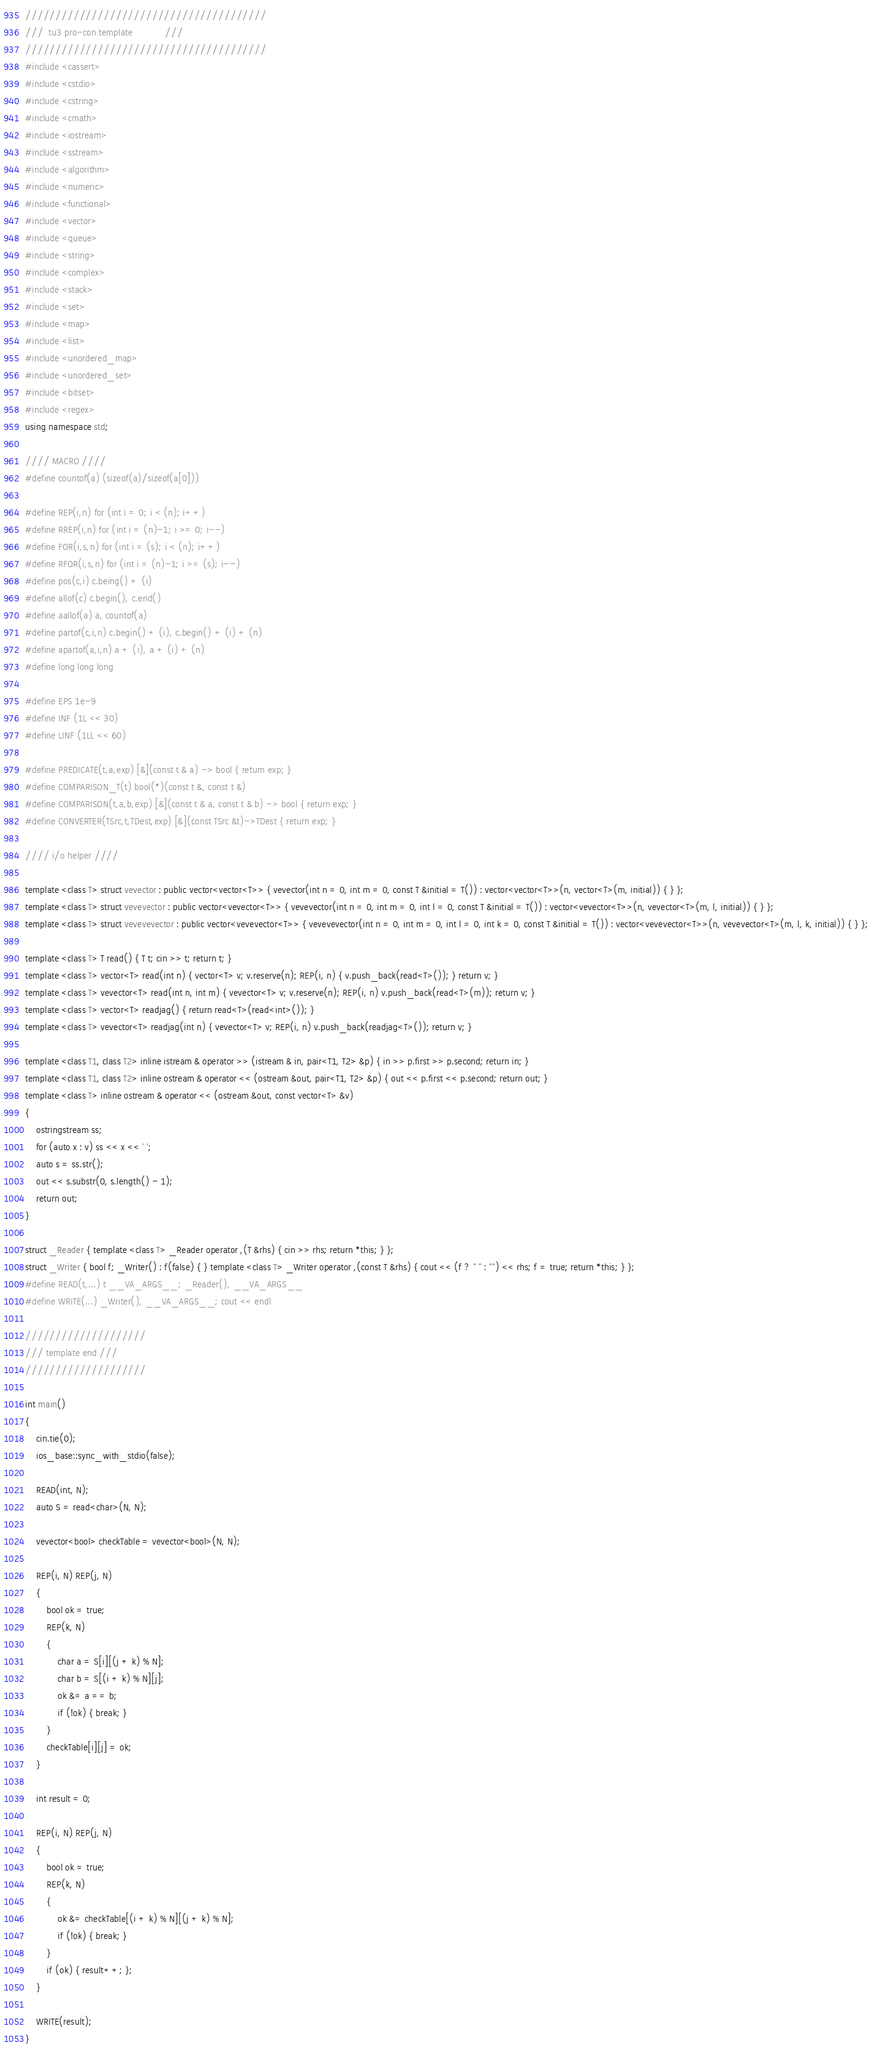Convert code to text. <code><loc_0><loc_0><loc_500><loc_500><_C++_>////////////////////////////////////////
///  tu3 pro-con template            ///
////////////////////////////////////////
#include <cassert>
#include <cstdio>
#include <cstring>
#include <cmath>
#include <iostream>
#include <sstream>
#include <algorithm>
#include <numeric>
#include <functional>
#include <vector>
#include <queue>
#include <string>
#include <complex>
#include <stack>
#include <set>
#include <map>
#include <list>
#include <unordered_map>
#include <unordered_set>
#include <bitset>
#include <regex>
using namespace std;

//// MACRO ////
#define countof(a) (sizeof(a)/sizeof(a[0]))

#define REP(i,n) for (int i = 0; i < (n); i++)
#define RREP(i,n) for (int i = (n)-1; i >= 0; i--)
#define FOR(i,s,n) for (int i = (s); i < (n); i++)
#define RFOR(i,s,n) for (int i = (n)-1; i >= (s); i--)
#define pos(c,i) c.being() + (i)
#define allof(c) c.begin(), c.end()
#define aallof(a) a, countof(a)
#define partof(c,i,n) c.begin() + (i), c.begin() + (i) + (n)
#define apartof(a,i,n) a + (i), a + (i) + (n)
#define long long long

#define EPS 1e-9
#define INF (1L << 30)
#define LINF (1LL << 60)

#define PREDICATE(t,a,exp) [&](const t & a) -> bool { return exp; }
#define COMPARISON_T(t) bool(*)(const t &, const t &)
#define COMPARISON(t,a,b,exp) [&](const t & a, const t & b) -> bool { return exp; }
#define CONVERTER(TSrc,t,TDest,exp) [&](const TSrc &t)->TDest { return exp; }

//// i/o helper ////

template <class T> struct vevector : public vector<vector<T>> { vevector(int n = 0, int m = 0, const T &initial = T()) : vector<vector<T>>(n, vector<T>(m, initial)) { } };
template <class T> struct vevevector : public vector<vevector<T>> { vevevector(int n = 0, int m = 0, int l = 0, const T &initial = T()) : vector<vevector<T>>(n, vevector<T>(m, l, initial)) { } };
template <class T> struct vevevevector : public vector<vevevector<T>> { vevevevector(int n = 0, int m = 0, int l = 0, int k = 0, const T &initial = T()) : vector<vevevector<T>>(n, vevevector<T>(m, l, k, initial)) { } };

template <class T> T read() { T t; cin >> t; return t; }
template <class T> vector<T> read(int n) { vector<T> v; v.reserve(n); REP(i, n) { v.push_back(read<T>()); } return v; }
template <class T> vevector<T> read(int n, int m) { vevector<T> v; v.reserve(n); REP(i, n) v.push_back(read<T>(m)); return v; }
template <class T> vector<T> readjag() { return read<T>(read<int>()); }
template <class T> vevector<T> readjag(int n) { vevector<T> v; REP(i, n) v.push_back(readjag<T>()); return v; }

template <class T1, class T2> inline istream & operator >> (istream & in, pair<T1, T2> &p) { in >> p.first >> p.second; return in; }
template <class T1, class T2> inline ostream & operator << (ostream &out, pair<T1, T2> &p) { out << p.first << p.second; return out; }
template <class T> inline ostream & operator << (ostream &out, const vector<T> &v)
{
	ostringstream ss;
	for (auto x : v) ss << x << ' ';
	auto s = ss.str();
	out << s.substr(0, s.length() - 1);
	return out;
}

struct _Reader { template <class T> _Reader operator ,(T &rhs) { cin >> rhs; return *this; } };
struct _Writer { bool f; _Writer() : f(false) { } template <class T> _Writer operator ,(const T &rhs) { cout << (f ? " " : "") << rhs; f = true; return *this; } };
#define READ(t,...) t __VA_ARGS__; _Reader(), __VA_ARGS__
#define WRITE(...) _Writer(), __VA_ARGS__; cout << endl

////////////////////
/// template end ///
////////////////////

int main()
{
	cin.tie(0);
	ios_base::sync_with_stdio(false);

	READ(int, N);
	auto S = read<char>(N, N);

	vevector<bool> checkTable = vevector<bool>(N, N);

	REP(i, N) REP(j, N)
	{
		bool ok = true;
		REP(k, N)
		{
			char a = S[i][(j + k) % N];
			char b = S[(i + k) % N][j];
			ok &= a == b;
			if (!ok) { break; }
		}
		checkTable[i][j] = ok;
	}

	int result = 0;

	REP(i, N) REP(j, N)
	{
		bool ok = true;
		REP(k, N)
		{
			ok &= checkTable[(i + k) % N][(j + k) % N];
			if (!ok) { break; }
		}
		if (ok) { result++; };
	}

	WRITE(result);
}

</code> 